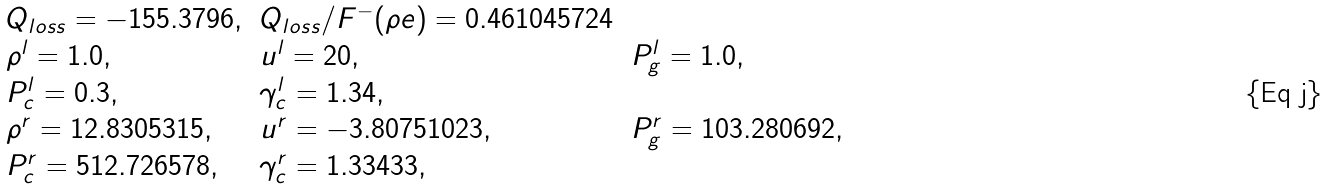<formula> <loc_0><loc_0><loc_500><loc_500>\begin{array} { l l l } Q _ { l o s s } = - 1 5 5 . 3 7 9 6 , & Q _ { l o s s } / F ^ { - } ( \rho e ) = 0 . 4 6 1 0 4 5 7 2 4 & \\ \rho ^ { l } = 1 . 0 , & u ^ { l } = 2 0 , & P _ { g } ^ { l } = 1 . 0 , \\ P _ { c } ^ { l } = 0 . 3 , & \gamma _ { c } ^ { l } = 1 . 3 4 , & \\ \rho ^ { r } = 1 2 . 8 3 0 5 3 1 5 , & u ^ { r } = - 3 . 8 0 7 5 1 0 2 3 , & P _ { g } ^ { r } = 1 0 3 . 2 8 0 6 9 2 , \\ P _ { c } ^ { r } = 5 1 2 . 7 2 6 5 7 8 , & \gamma _ { c } ^ { r } = 1 . 3 3 4 3 3 , & \end{array}</formula> 